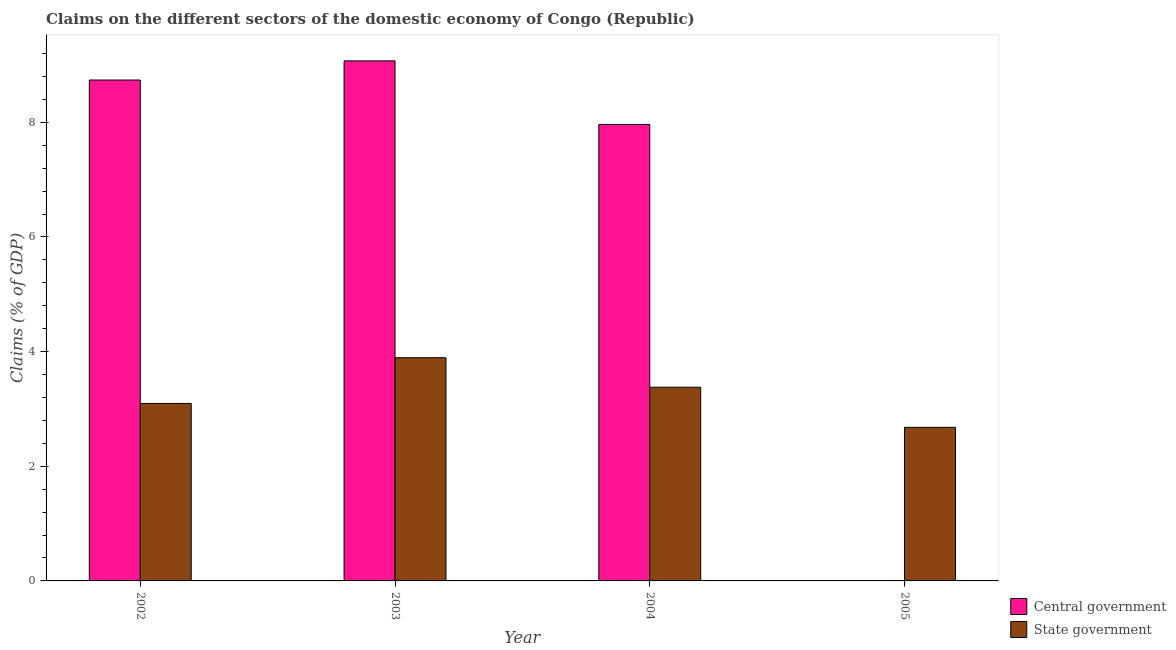How many different coloured bars are there?
Ensure brevity in your answer.  2. Are the number of bars per tick equal to the number of legend labels?
Offer a very short reply. No. How many bars are there on the 2nd tick from the left?
Your answer should be very brief. 2. How many bars are there on the 2nd tick from the right?
Offer a very short reply. 2. What is the label of the 2nd group of bars from the left?
Your answer should be very brief. 2003. In how many cases, is the number of bars for a given year not equal to the number of legend labels?
Provide a succinct answer. 1. What is the claims on state government in 2005?
Your response must be concise. 2.68. Across all years, what is the maximum claims on central government?
Your response must be concise. 9.07. What is the total claims on state government in the graph?
Your answer should be compact. 13.05. What is the difference between the claims on state government in 2003 and that in 2004?
Offer a very short reply. 0.51. What is the difference between the claims on central government in 2005 and the claims on state government in 2004?
Provide a succinct answer. -7.96. What is the average claims on state government per year?
Offer a terse response. 3.26. In the year 2004, what is the difference between the claims on central government and claims on state government?
Ensure brevity in your answer.  0. What is the ratio of the claims on state government in 2004 to that in 2005?
Keep it short and to the point. 1.26. Is the difference between the claims on state government in 2004 and 2005 greater than the difference between the claims on central government in 2004 and 2005?
Give a very brief answer. No. What is the difference between the highest and the second highest claims on state government?
Give a very brief answer. 0.51. What is the difference between the highest and the lowest claims on central government?
Your answer should be compact. 9.07. Is the sum of the claims on state government in 2002 and 2004 greater than the maximum claims on central government across all years?
Provide a succinct answer. Yes. How many years are there in the graph?
Your answer should be very brief. 4. Where does the legend appear in the graph?
Your answer should be compact. Bottom right. How many legend labels are there?
Provide a short and direct response. 2. How are the legend labels stacked?
Offer a very short reply. Vertical. What is the title of the graph?
Your answer should be compact. Claims on the different sectors of the domestic economy of Congo (Republic). What is the label or title of the X-axis?
Provide a succinct answer. Year. What is the label or title of the Y-axis?
Your answer should be very brief. Claims (% of GDP). What is the Claims (% of GDP) in Central government in 2002?
Your answer should be compact. 8.74. What is the Claims (% of GDP) of State government in 2002?
Offer a very short reply. 3.1. What is the Claims (% of GDP) of Central government in 2003?
Your response must be concise. 9.07. What is the Claims (% of GDP) of State government in 2003?
Offer a terse response. 3.89. What is the Claims (% of GDP) of Central government in 2004?
Provide a short and direct response. 7.96. What is the Claims (% of GDP) in State government in 2004?
Ensure brevity in your answer.  3.38. What is the Claims (% of GDP) in Central government in 2005?
Provide a short and direct response. 0. What is the Claims (% of GDP) of State government in 2005?
Your response must be concise. 2.68. Across all years, what is the maximum Claims (% of GDP) in Central government?
Offer a very short reply. 9.07. Across all years, what is the maximum Claims (% of GDP) in State government?
Offer a terse response. 3.89. Across all years, what is the minimum Claims (% of GDP) in Central government?
Your response must be concise. 0. Across all years, what is the minimum Claims (% of GDP) of State government?
Ensure brevity in your answer.  2.68. What is the total Claims (% of GDP) in Central government in the graph?
Provide a succinct answer. 25.77. What is the total Claims (% of GDP) of State government in the graph?
Give a very brief answer. 13.05. What is the difference between the Claims (% of GDP) in Central government in 2002 and that in 2003?
Make the answer very short. -0.33. What is the difference between the Claims (% of GDP) of State government in 2002 and that in 2003?
Keep it short and to the point. -0.8. What is the difference between the Claims (% of GDP) in Central government in 2002 and that in 2004?
Provide a succinct answer. 0.77. What is the difference between the Claims (% of GDP) of State government in 2002 and that in 2004?
Your response must be concise. -0.28. What is the difference between the Claims (% of GDP) in State government in 2002 and that in 2005?
Give a very brief answer. 0.42. What is the difference between the Claims (% of GDP) of Central government in 2003 and that in 2004?
Keep it short and to the point. 1.11. What is the difference between the Claims (% of GDP) in State government in 2003 and that in 2004?
Provide a succinct answer. 0.52. What is the difference between the Claims (% of GDP) of State government in 2003 and that in 2005?
Your answer should be very brief. 1.21. What is the difference between the Claims (% of GDP) of State government in 2004 and that in 2005?
Offer a very short reply. 0.7. What is the difference between the Claims (% of GDP) in Central government in 2002 and the Claims (% of GDP) in State government in 2003?
Offer a terse response. 4.84. What is the difference between the Claims (% of GDP) in Central government in 2002 and the Claims (% of GDP) in State government in 2004?
Ensure brevity in your answer.  5.36. What is the difference between the Claims (% of GDP) of Central government in 2002 and the Claims (% of GDP) of State government in 2005?
Offer a very short reply. 6.06. What is the difference between the Claims (% of GDP) of Central government in 2003 and the Claims (% of GDP) of State government in 2004?
Provide a short and direct response. 5.69. What is the difference between the Claims (% of GDP) in Central government in 2003 and the Claims (% of GDP) in State government in 2005?
Ensure brevity in your answer.  6.39. What is the difference between the Claims (% of GDP) of Central government in 2004 and the Claims (% of GDP) of State government in 2005?
Your answer should be very brief. 5.28. What is the average Claims (% of GDP) of Central government per year?
Offer a terse response. 6.44. What is the average Claims (% of GDP) in State government per year?
Your response must be concise. 3.26. In the year 2002, what is the difference between the Claims (% of GDP) of Central government and Claims (% of GDP) of State government?
Your answer should be very brief. 5.64. In the year 2003, what is the difference between the Claims (% of GDP) of Central government and Claims (% of GDP) of State government?
Your answer should be very brief. 5.18. In the year 2004, what is the difference between the Claims (% of GDP) of Central government and Claims (% of GDP) of State government?
Provide a succinct answer. 4.58. What is the ratio of the Claims (% of GDP) of Central government in 2002 to that in 2003?
Ensure brevity in your answer.  0.96. What is the ratio of the Claims (% of GDP) of State government in 2002 to that in 2003?
Your answer should be compact. 0.8. What is the ratio of the Claims (% of GDP) of Central government in 2002 to that in 2004?
Keep it short and to the point. 1.1. What is the ratio of the Claims (% of GDP) in State government in 2002 to that in 2004?
Ensure brevity in your answer.  0.92. What is the ratio of the Claims (% of GDP) of State government in 2002 to that in 2005?
Your answer should be very brief. 1.16. What is the ratio of the Claims (% of GDP) in Central government in 2003 to that in 2004?
Provide a succinct answer. 1.14. What is the ratio of the Claims (% of GDP) of State government in 2003 to that in 2004?
Offer a very short reply. 1.15. What is the ratio of the Claims (% of GDP) in State government in 2003 to that in 2005?
Ensure brevity in your answer.  1.45. What is the ratio of the Claims (% of GDP) of State government in 2004 to that in 2005?
Make the answer very short. 1.26. What is the difference between the highest and the second highest Claims (% of GDP) of Central government?
Make the answer very short. 0.33. What is the difference between the highest and the second highest Claims (% of GDP) of State government?
Provide a succinct answer. 0.52. What is the difference between the highest and the lowest Claims (% of GDP) in Central government?
Ensure brevity in your answer.  9.07. What is the difference between the highest and the lowest Claims (% of GDP) of State government?
Keep it short and to the point. 1.21. 